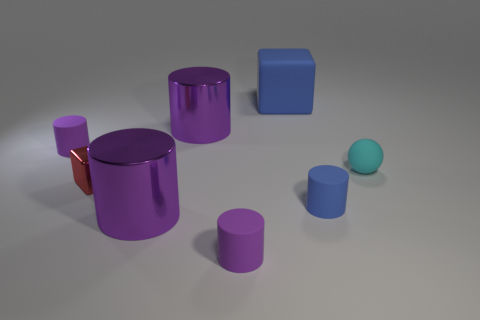How many purple cylinders must be subtracted to get 1 purple cylinders? 3 Subtract all gray balls. How many purple cylinders are left? 4 Subtract all metal cylinders. How many cylinders are left? 3 Subtract all blue cylinders. How many cylinders are left? 4 Subtract all blue cylinders. Subtract all cyan blocks. How many cylinders are left? 4 Add 1 small cyan metallic things. How many objects exist? 9 Subtract all cubes. How many objects are left? 6 Add 6 metallic blocks. How many metallic blocks exist? 7 Subtract 0 green cylinders. How many objects are left? 8 Subtract all small cyan things. Subtract all small rubber balls. How many objects are left? 6 